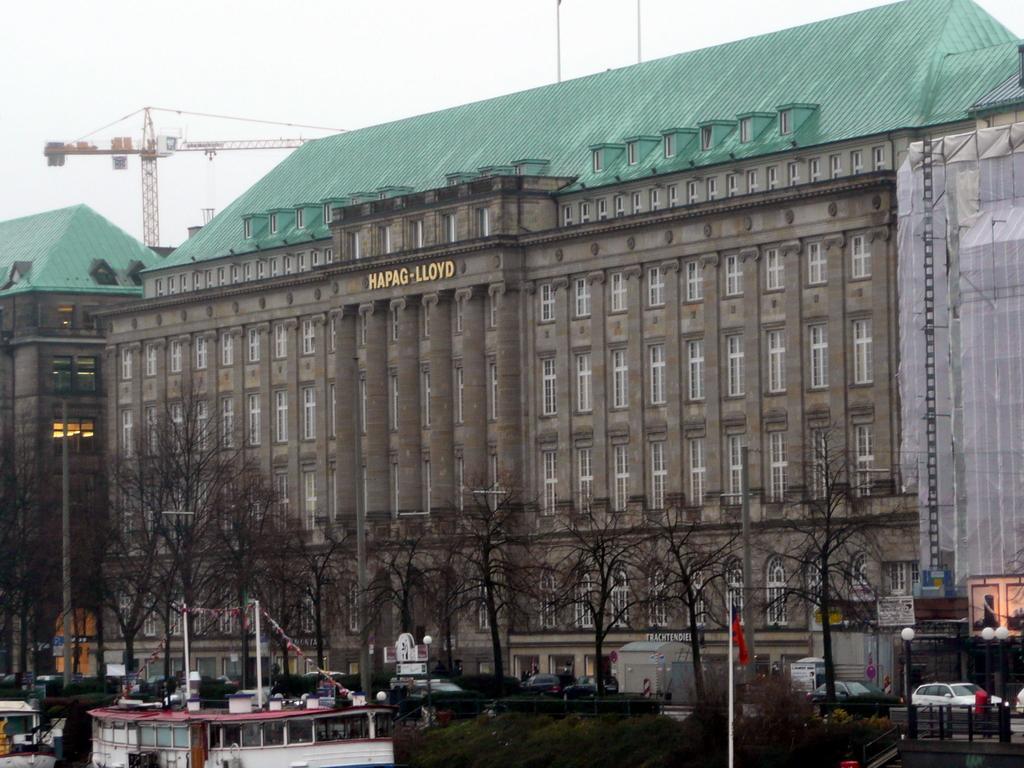How would you summarize this image in a sentence or two? In this image in the middle there are buildings, trees, boats, vehicles, poles, street lights, flag, tower and sky. 